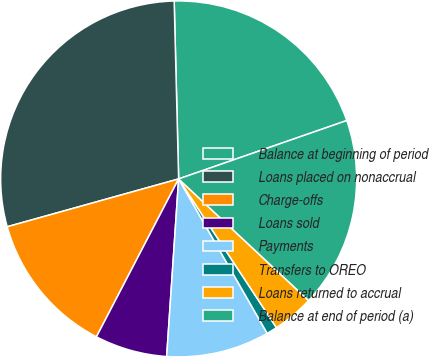<chart> <loc_0><loc_0><loc_500><loc_500><pie_chart><fcel>Balance at beginning of period<fcel>Loans placed on nonaccrual<fcel>Charge-offs<fcel>Loans sold<fcel>Payments<fcel>Transfers to OREO<fcel>Loans returned to accrual<fcel>Balance at end of period (a)<nl><fcel>20.08%<fcel>28.93%<fcel>13.03%<fcel>6.57%<fcel>9.36%<fcel>0.97%<fcel>3.77%<fcel>17.29%<nl></chart> 